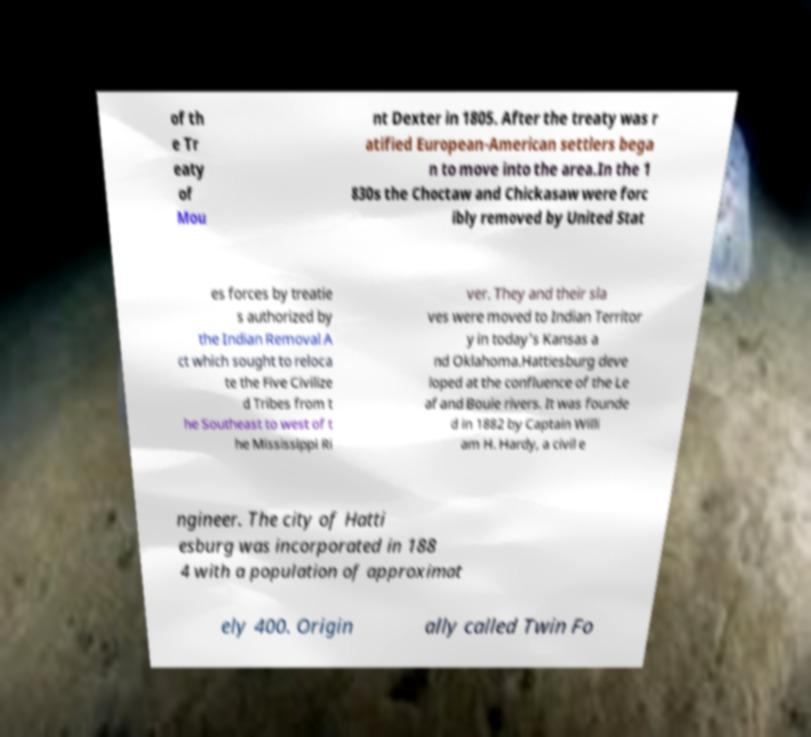For documentation purposes, I need the text within this image transcribed. Could you provide that? of th e Tr eaty of Mou nt Dexter in 1805. After the treaty was r atified European-American settlers bega n to move into the area.In the 1 830s the Choctaw and Chickasaw were forc ibly removed by United Stat es forces by treatie s authorized by the Indian Removal A ct which sought to reloca te the Five Civilize d Tribes from t he Southeast to west of t he Mississippi Ri ver. They and their sla ves were moved to Indian Territor y in today's Kansas a nd Oklahoma.Hattiesburg deve loped at the confluence of the Le af and Bouie rivers. It was founde d in 1882 by Captain Willi am H. Hardy, a civil e ngineer. The city of Hatti esburg was incorporated in 188 4 with a population of approximat ely 400. Origin ally called Twin Fo 